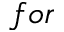<formula> <loc_0><loc_0><loc_500><loc_500>f o r</formula> 